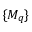<formula> <loc_0><loc_0><loc_500><loc_500>\{ M _ { q } \}</formula> 